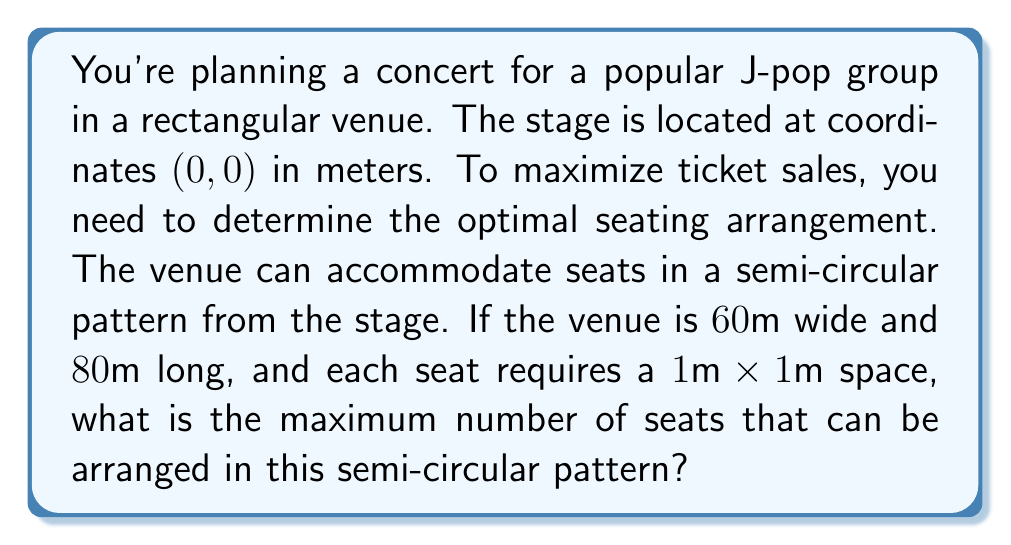Can you answer this question? Let's approach this step-by-step:

1) The stage is at (0, 0), and we're creating a semi-circular seating arrangement.

2) The venue is 60m wide, so the radius of our semi-circle can't exceed 30m (half the width).

3) The area of a full circle is $A = \pi r^2$. For a semi-circle, it's half of this: $A = \frac{1}{2}\pi r^2$.

4) We need to find the largest possible radius that fits within the venue. The venue is 80m long, so our radius can be at most 80m.

5) However, we're limited by the width (60m), so our maximum radius is 30m.

6) The area of our semi-circle seating arrangement is:

   $A = \frac{1}{2}\pi r^2 = \frac{1}{2}\pi (30)^2 = 1413.72$ m²

7) Each seat occupies 1m², so the number of seats is equal to the area in m².

8) However, we need to round down to the nearest whole number, as we can't have partial seats.

Therefore, the maximum number of seats is the floor of 1413.72, which is 1413.

[asy]
import geometry;

size(200);
draw((-30,0)--(30,0), arrow=Arrow);
draw((0,-10)--(0,80), arrow=Arrow);
draw(arc((0,0), 30, 0, 180));
dot((0,0));
label("Stage (0,0)", (0,-5), S);
label("30m", (15,0), S);
label("80m", (0,40), E);
[/asy]
Answer: 1413 seats 